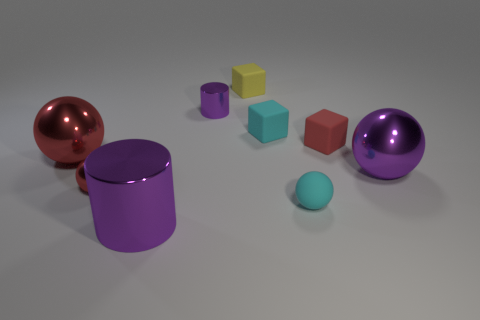What is the size of the cyan thing that is made of the same material as the tiny cyan cube? The size of the cyan object, which appears to be a cube and is presumably made of the same material as the smaller cyan cube, is larger than the tiny cube but smaller when compared to other objects in the image, such as the large spheres and cylinders. 